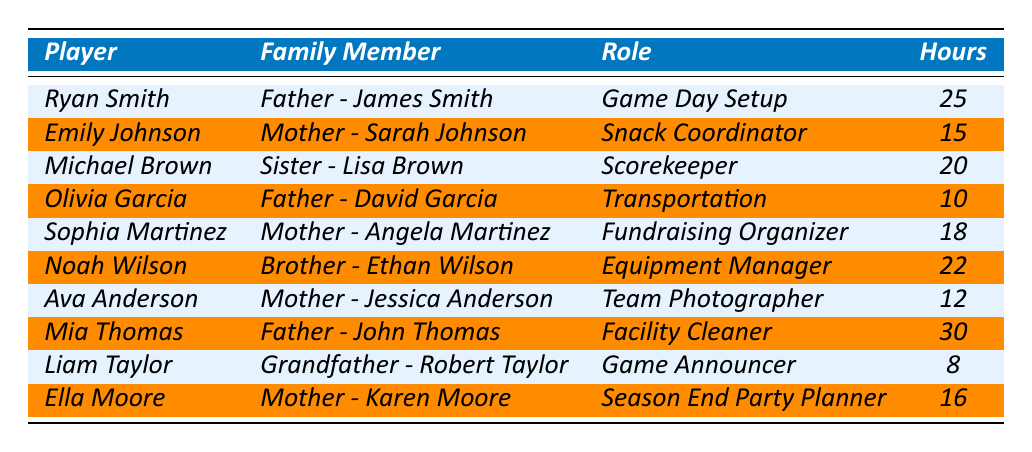What is the total number of volunteer hours contributed by family members? To find the total volunteer hours, we add the hours from each entry in the table: 25 + 15 + 20 + 10 + 18 + 22 + 12 + 30 + 8 + 16 =  176 hours
Answer: 176 hours Which family member contributed the most hours? The highest number of hours is 30, contributed by Mia Thomas's father, John Thomas, who served as the Facility Cleaner
Answer: John Thomas How many players’ families had a role in game day activities? The roles associated with game day activities are Game Day Setup and Game Announcer. This includes Ryan Smith (25 hours) and Liam Taylor (8 hours), totaling 2 players
Answer: 2 players What is the average number of hours contributed by mothers? The mothers in the table are Sarah Johnson, Angela Martinez, Jessica Anderson, Karen Moore, contributing 15, 18, 12, and 16 hours, respectively. The total hours contributed by mothers is 15 + 18 + 12 + 16 = 61 hours. There are 4 mothers, so the average is 61 / 4 = 15.25 hours
Answer: 15.25 hours Is there any family member who contributed fewer than 10 hours? Yes, Liam Taylor's grandfather, Robert Taylor, contributed only 8 hours as the Game Announcer
Answer: Yes Which player’s family contributed the least volunteer hours? The least number of hours is 8 contributed by Liam Taylor's grandfather, Robert Taylor, who was the Game Announcer
Answer: Liam Taylor How many hours did Noah Wilson’s family contribute compared to Emily Johnson's family? Noah Wilson's family contributed 22 hours, while Emily Johnson's family contributed 15 hours. The difference in hours contributed is 22 - 15 = 7 hours
Answer: 7 hours List the roles that contributed more than 20 hours. The roles with contributions of more than 20 hours are Game Day Setup (25 hours), Scorekeeper (20 hours), Equipment Manager (22 hours), and Facility Cleaner (30 hours)
Answer: Game Day Setup, Equipment Manager, Facility Cleaner What percentage of total volunteer hours were contributed by the player with the highest hours? Mia Thomas's family contributed 30 hours. To find the percentage: (30 / 176) * 100 = 17.05%. Thus, around 17.05% of the total volunteer hours were contributed by her family
Answer: 17.05% Which roles were not performed by any family members? Every listed role has at least one family member contributing hours, with no roles unaccounted for, as listed in the table
Answer: None 